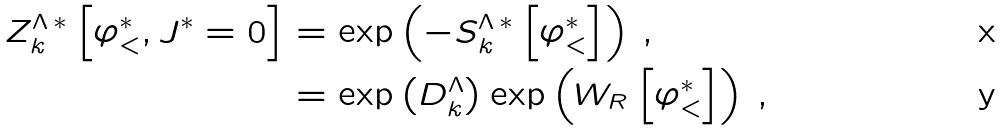Convert formula to latex. <formula><loc_0><loc_0><loc_500><loc_500>Z ^ { \Lambda \, * } _ { k } \left [ \varphi _ { < } ^ { * } , J ^ { * } = 0 \right ] & = \exp \left ( - S ^ { \Lambda \, * } _ { k } \left [ \varphi _ { < } ^ { * } \right ] \right ) \, , \\ & = \exp \left ( D ^ { \Lambda } _ { k } \right ) \exp \left ( W _ { R } \left [ \varphi _ { < } ^ { * } \right ] \right ) \, ,</formula> 